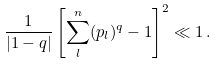<formula> <loc_0><loc_0><loc_500><loc_500>\frac { 1 } { | 1 - q | } \left [ \sum _ { l } ^ { n } ( p _ { l } ) ^ { q } - 1 \right ] ^ { 2 } \ll 1 \, .</formula> 